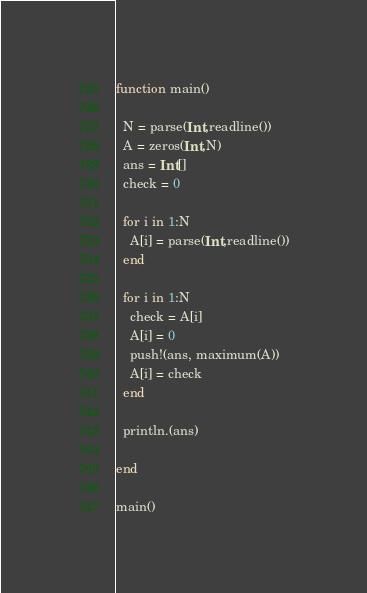<code> <loc_0><loc_0><loc_500><loc_500><_Julia_>function main()
  
  N = parse(Int,readline())
  A = zeros(Int,N)
  ans = Int[]
  check = 0
  
  for i in 1:N
    A[i] = parse(Int,readline())
  end
  
  for i in 1:N
    check = A[i]
    A[i] = 0
    push!(ans, maximum(A))
    A[i] = check
  end
  
  println.(ans)
  
end

main()</code> 